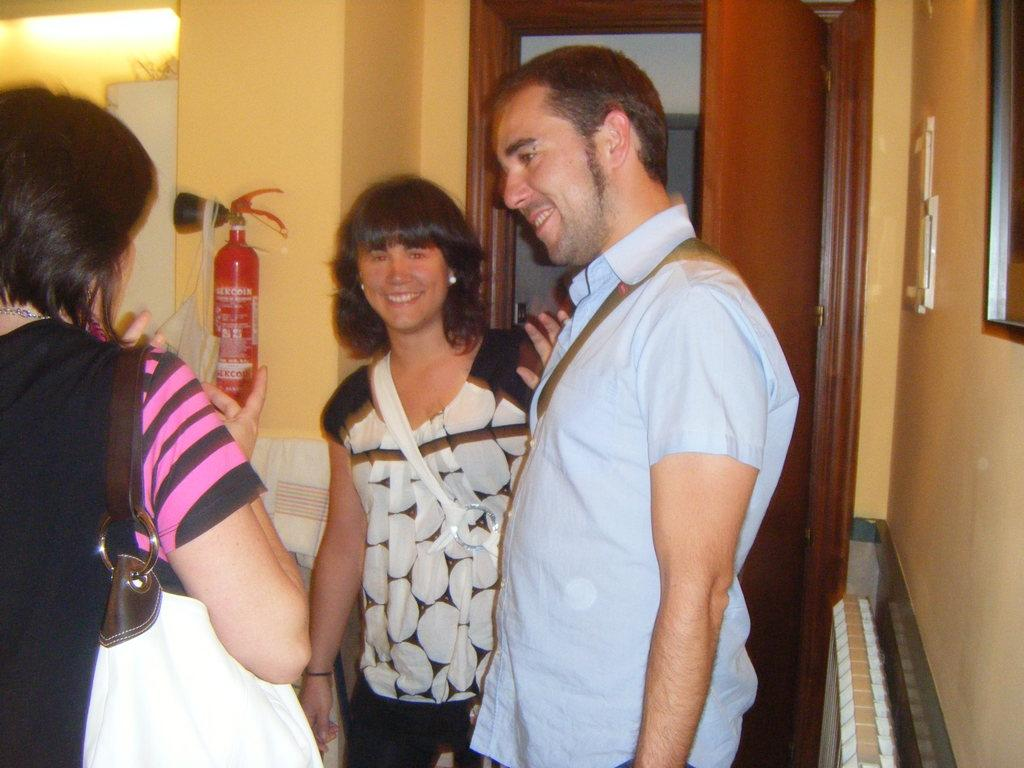How many people are in the image? There are three people in the image. Can you describe the gender of the people in the image? Two of them are women, and one of them is a man. What safety equipment is present in the image? There is a fire extinguisher on the wall. What architectural feature can be seen in the background? There is a door visible in the background. What type of bells can be heard ringing in the image? There are no bells present in the image, and therefore no sound can be heard. 